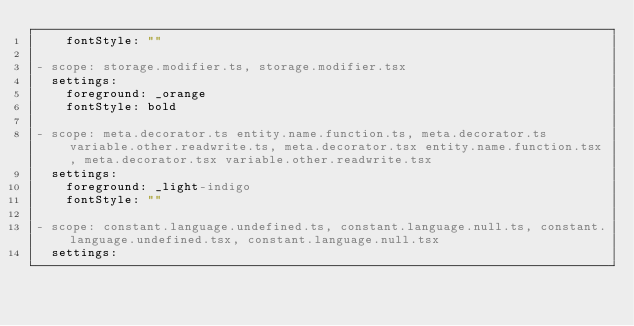Convert code to text. <code><loc_0><loc_0><loc_500><loc_500><_YAML_>    fontStyle: ""

- scope: storage.modifier.ts, storage.modifier.tsx
  settings:
    foreground: _orange
    fontStyle: bold

- scope: meta.decorator.ts entity.name.function.ts, meta.decorator.ts variable.other.readwrite.ts, meta.decorator.tsx entity.name.function.tsx, meta.decorator.tsx variable.other.readwrite.tsx
  settings:
    foreground: _light-indigo
    fontStyle: ""

- scope: constant.language.undefined.ts, constant.language.null.ts, constant.language.undefined.tsx, constant.language.null.tsx
  settings:</code> 